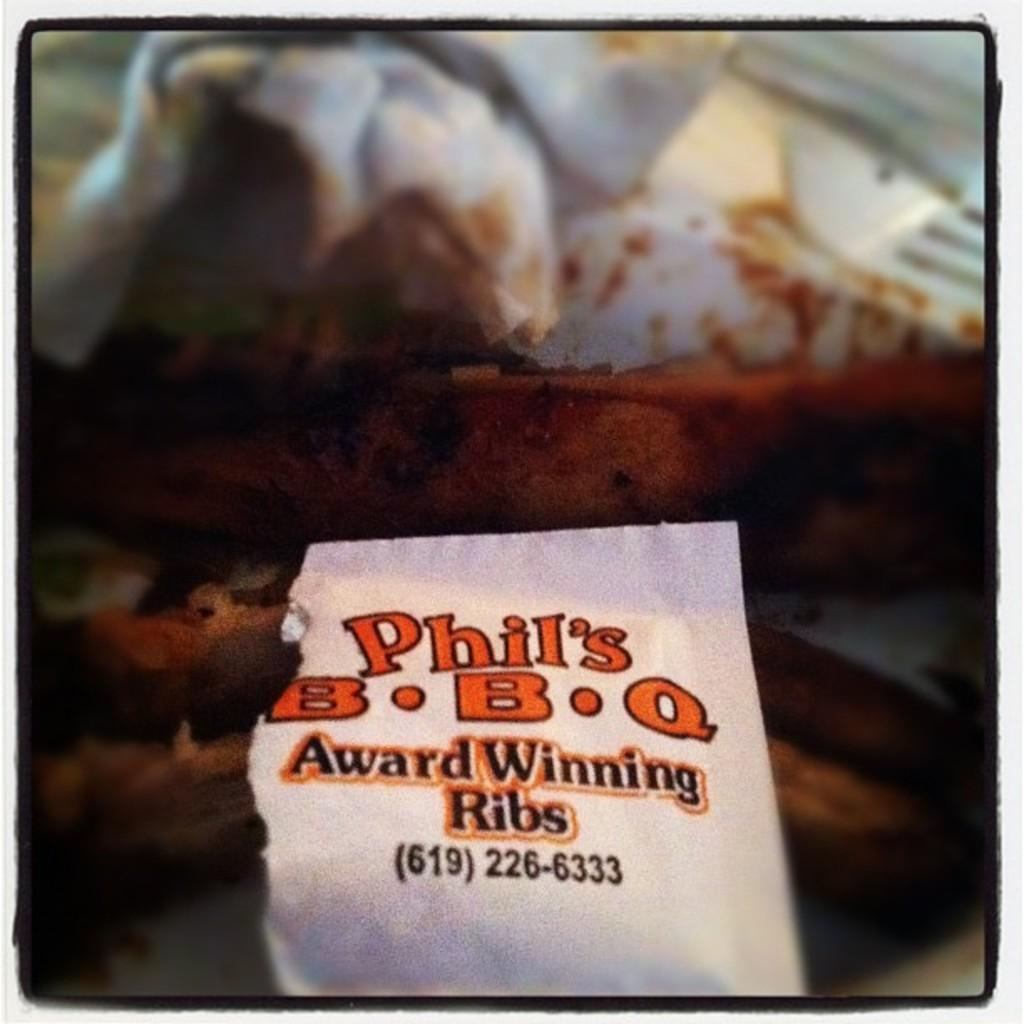What is the main subject in the center of the image? There are tissue papers in the center of the image. What else can be seen in the image besides the tissue papers? There are food items in the image. Can you describe the text on the paper in the image? There is a paper with the text "Award Winning Ribs" in the image. What type of gate can be seen in the image? There is no gate present in the image. Is there a grassy area visible in the image? There is no grassy area visible in the image. 